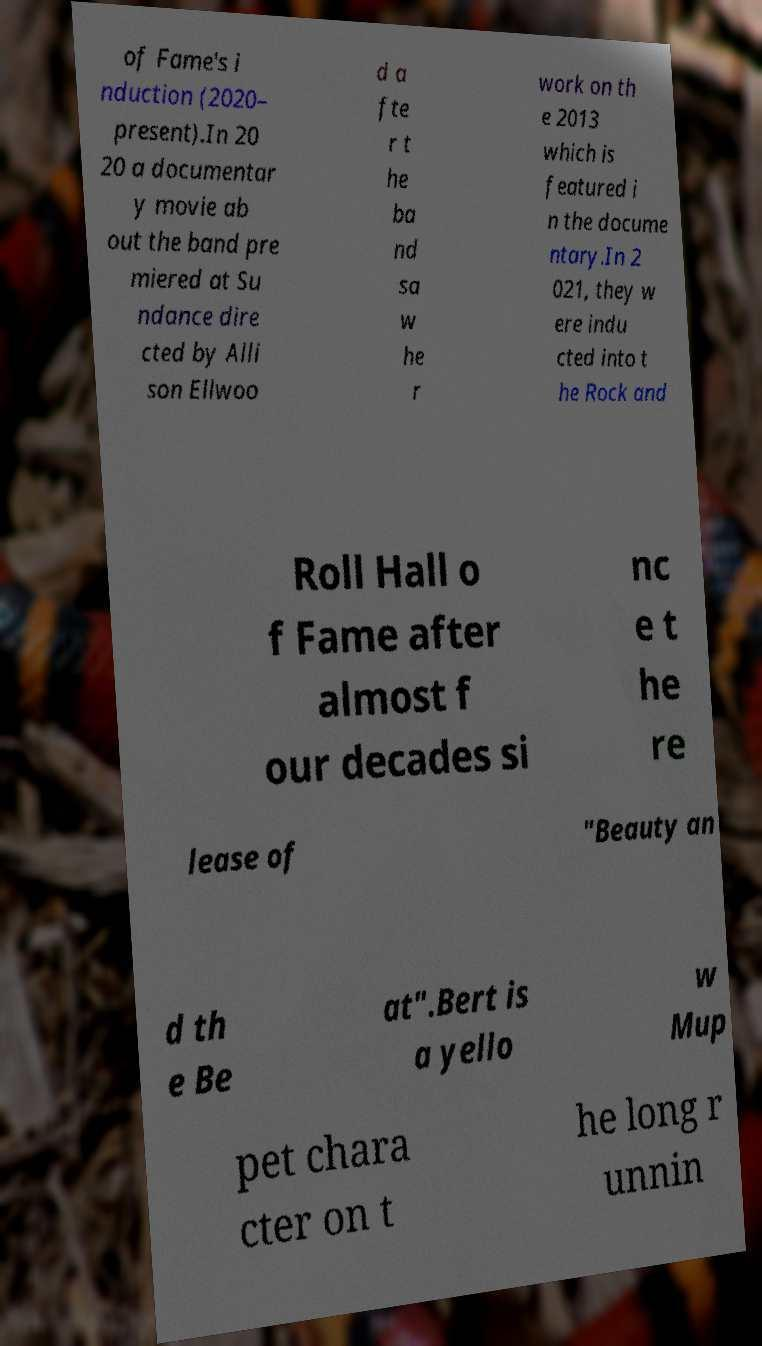Could you extract and type out the text from this image? of Fame's i nduction (2020– present).In 20 20 a documentar y movie ab out the band pre miered at Su ndance dire cted by Alli son Ellwoo d a fte r t he ba nd sa w he r work on th e 2013 which is featured i n the docume ntary.In 2 021, they w ere indu cted into t he Rock and Roll Hall o f Fame after almost f our decades si nc e t he re lease of "Beauty an d th e Be at".Bert is a yello w Mup pet chara cter on t he long r unnin 